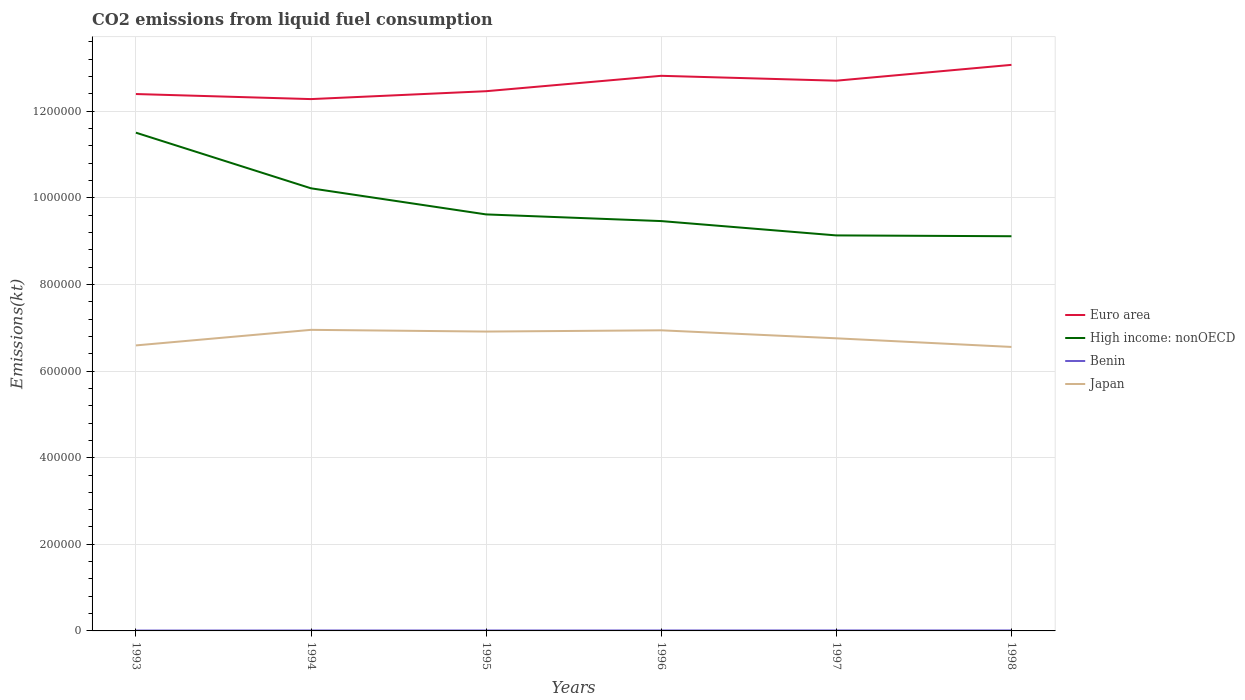Does the line corresponding to High income: nonOECD intersect with the line corresponding to Japan?
Give a very brief answer. No. Across all years, what is the maximum amount of CO2 emitted in Japan?
Your answer should be compact. 6.56e+05. What is the total amount of CO2 emitted in Euro area in the graph?
Your answer should be very brief. -6538.26. What is the difference between the highest and the second highest amount of CO2 emitted in Japan?
Provide a succinct answer. 3.95e+04. Is the amount of CO2 emitted in Euro area strictly greater than the amount of CO2 emitted in Benin over the years?
Your answer should be very brief. No. How many lines are there?
Make the answer very short. 4. How many years are there in the graph?
Provide a succinct answer. 6. Are the values on the major ticks of Y-axis written in scientific E-notation?
Offer a terse response. No. Where does the legend appear in the graph?
Provide a short and direct response. Center right. What is the title of the graph?
Keep it short and to the point. CO2 emissions from liquid fuel consumption. What is the label or title of the X-axis?
Your answer should be compact. Years. What is the label or title of the Y-axis?
Provide a short and direct response. Emissions(kt). What is the Emissions(kt) of Euro area in 1993?
Your answer should be very brief. 1.24e+06. What is the Emissions(kt) in High income: nonOECD in 1993?
Offer a very short reply. 1.15e+06. What is the Emissions(kt) of Benin in 1993?
Your answer should be compact. 880.08. What is the Emissions(kt) of Japan in 1993?
Provide a succinct answer. 6.59e+05. What is the Emissions(kt) of Euro area in 1994?
Your answer should be compact. 1.23e+06. What is the Emissions(kt) in High income: nonOECD in 1994?
Make the answer very short. 1.02e+06. What is the Emissions(kt) in Benin in 1994?
Keep it short and to the point. 1034.09. What is the Emissions(kt) in Japan in 1994?
Make the answer very short. 6.95e+05. What is the Emissions(kt) of Euro area in 1995?
Ensure brevity in your answer.  1.25e+06. What is the Emissions(kt) in High income: nonOECD in 1995?
Make the answer very short. 9.62e+05. What is the Emissions(kt) of Benin in 1995?
Your answer should be very brief. 1037.76. What is the Emissions(kt) of Japan in 1995?
Keep it short and to the point. 6.91e+05. What is the Emissions(kt) of Euro area in 1996?
Your answer should be compact. 1.28e+06. What is the Emissions(kt) of High income: nonOECD in 1996?
Keep it short and to the point. 9.46e+05. What is the Emissions(kt) of Benin in 1996?
Provide a short and direct response. 1085.43. What is the Emissions(kt) of Japan in 1996?
Keep it short and to the point. 6.94e+05. What is the Emissions(kt) in Euro area in 1997?
Your answer should be very brief. 1.27e+06. What is the Emissions(kt) of High income: nonOECD in 1997?
Make the answer very short. 9.13e+05. What is the Emissions(kt) in Benin in 1997?
Provide a succinct answer. 1118.43. What is the Emissions(kt) in Japan in 1997?
Provide a short and direct response. 6.76e+05. What is the Emissions(kt) in Euro area in 1998?
Your answer should be very brief. 1.31e+06. What is the Emissions(kt) in High income: nonOECD in 1998?
Ensure brevity in your answer.  9.11e+05. What is the Emissions(kt) in Benin in 1998?
Offer a very short reply. 1114.77. What is the Emissions(kt) of Japan in 1998?
Your answer should be very brief. 6.56e+05. Across all years, what is the maximum Emissions(kt) in Euro area?
Offer a terse response. 1.31e+06. Across all years, what is the maximum Emissions(kt) in High income: nonOECD?
Offer a very short reply. 1.15e+06. Across all years, what is the maximum Emissions(kt) of Benin?
Offer a terse response. 1118.43. Across all years, what is the maximum Emissions(kt) of Japan?
Give a very brief answer. 6.95e+05. Across all years, what is the minimum Emissions(kt) of Euro area?
Provide a short and direct response. 1.23e+06. Across all years, what is the minimum Emissions(kt) in High income: nonOECD?
Ensure brevity in your answer.  9.11e+05. Across all years, what is the minimum Emissions(kt) in Benin?
Provide a succinct answer. 880.08. Across all years, what is the minimum Emissions(kt) in Japan?
Provide a succinct answer. 6.56e+05. What is the total Emissions(kt) in Euro area in the graph?
Keep it short and to the point. 7.57e+06. What is the total Emissions(kt) in High income: nonOECD in the graph?
Ensure brevity in your answer.  5.91e+06. What is the total Emissions(kt) in Benin in the graph?
Give a very brief answer. 6270.57. What is the total Emissions(kt) of Japan in the graph?
Offer a terse response. 4.07e+06. What is the difference between the Emissions(kt) in Euro area in 1993 and that in 1994?
Make the answer very short. 1.17e+04. What is the difference between the Emissions(kt) in High income: nonOECD in 1993 and that in 1994?
Make the answer very short. 1.29e+05. What is the difference between the Emissions(kt) of Benin in 1993 and that in 1994?
Make the answer very short. -154.01. What is the difference between the Emissions(kt) in Japan in 1993 and that in 1994?
Give a very brief answer. -3.60e+04. What is the difference between the Emissions(kt) of Euro area in 1993 and that in 1995?
Ensure brevity in your answer.  -6538.26. What is the difference between the Emissions(kt) in High income: nonOECD in 1993 and that in 1995?
Provide a short and direct response. 1.89e+05. What is the difference between the Emissions(kt) in Benin in 1993 and that in 1995?
Give a very brief answer. -157.68. What is the difference between the Emissions(kt) of Japan in 1993 and that in 1995?
Your response must be concise. -3.20e+04. What is the difference between the Emissions(kt) of Euro area in 1993 and that in 1996?
Your answer should be very brief. -4.21e+04. What is the difference between the Emissions(kt) in High income: nonOECD in 1993 and that in 1996?
Keep it short and to the point. 2.04e+05. What is the difference between the Emissions(kt) in Benin in 1993 and that in 1996?
Provide a short and direct response. -205.35. What is the difference between the Emissions(kt) in Japan in 1993 and that in 1996?
Offer a terse response. -3.49e+04. What is the difference between the Emissions(kt) in Euro area in 1993 and that in 1997?
Your answer should be compact. -3.08e+04. What is the difference between the Emissions(kt) in High income: nonOECD in 1993 and that in 1997?
Provide a short and direct response. 2.37e+05. What is the difference between the Emissions(kt) in Benin in 1993 and that in 1997?
Your answer should be compact. -238.35. What is the difference between the Emissions(kt) in Japan in 1993 and that in 1997?
Provide a short and direct response. -1.64e+04. What is the difference between the Emissions(kt) in Euro area in 1993 and that in 1998?
Give a very brief answer. -6.74e+04. What is the difference between the Emissions(kt) of High income: nonOECD in 1993 and that in 1998?
Your response must be concise. 2.39e+05. What is the difference between the Emissions(kt) in Benin in 1993 and that in 1998?
Keep it short and to the point. -234.69. What is the difference between the Emissions(kt) of Japan in 1993 and that in 1998?
Provide a short and direct response. 3527.65. What is the difference between the Emissions(kt) of Euro area in 1994 and that in 1995?
Your response must be concise. -1.82e+04. What is the difference between the Emissions(kt) in High income: nonOECD in 1994 and that in 1995?
Offer a very short reply. 6.02e+04. What is the difference between the Emissions(kt) of Benin in 1994 and that in 1995?
Your response must be concise. -3.67. What is the difference between the Emissions(kt) of Japan in 1994 and that in 1995?
Your answer should be very brief. 3967.69. What is the difference between the Emissions(kt) of Euro area in 1994 and that in 1996?
Provide a succinct answer. -5.38e+04. What is the difference between the Emissions(kt) in High income: nonOECD in 1994 and that in 1996?
Ensure brevity in your answer.  7.56e+04. What is the difference between the Emissions(kt) in Benin in 1994 and that in 1996?
Your answer should be compact. -51.34. What is the difference between the Emissions(kt) in Japan in 1994 and that in 1996?
Your response must be concise. 1092.77. What is the difference between the Emissions(kt) of Euro area in 1994 and that in 1997?
Provide a short and direct response. -4.25e+04. What is the difference between the Emissions(kt) in High income: nonOECD in 1994 and that in 1997?
Provide a short and direct response. 1.09e+05. What is the difference between the Emissions(kt) of Benin in 1994 and that in 1997?
Your response must be concise. -84.34. What is the difference between the Emissions(kt) of Japan in 1994 and that in 1997?
Your answer should be very brief. 1.96e+04. What is the difference between the Emissions(kt) in Euro area in 1994 and that in 1998?
Provide a short and direct response. -7.91e+04. What is the difference between the Emissions(kt) in High income: nonOECD in 1994 and that in 1998?
Make the answer very short. 1.11e+05. What is the difference between the Emissions(kt) in Benin in 1994 and that in 1998?
Offer a terse response. -80.67. What is the difference between the Emissions(kt) in Japan in 1994 and that in 1998?
Your response must be concise. 3.95e+04. What is the difference between the Emissions(kt) of Euro area in 1995 and that in 1996?
Your answer should be compact. -3.56e+04. What is the difference between the Emissions(kt) of High income: nonOECD in 1995 and that in 1996?
Provide a short and direct response. 1.54e+04. What is the difference between the Emissions(kt) of Benin in 1995 and that in 1996?
Your answer should be compact. -47.67. What is the difference between the Emissions(kt) of Japan in 1995 and that in 1996?
Give a very brief answer. -2874.93. What is the difference between the Emissions(kt) of Euro area in 1995 and that in 1997?
Keep it short and to the point. -2.43e+04. What is the difference between the Emissions(kt) of High income: nonOECD in 1995 and that in 1997?
Provide a short and direct response. 4.85e+04. What is the difference between the Emissions(kt) of Benin in 1995 and that in 1997?
Your answer should be compact. -80.67. What is the difference between the Emissions(kt) of Japan in 1995 and that in 1997?
Your answer should be compact. 1.56e+04. What is the difference between the Emissions(kt) of Euro area in 1995 and that in 1998?
Make the answer very short. -6.08e+04. What is the difference between the Emissions(kt) of High income: nonOECD in 1995 and that in 1998?
Keep it short and to the point. 5.04e+04. What is the difference between the Emissions(kt) of Benin in 1995 and that in 1998?
Provide a succinct answer. -77.01. What is the difference between the Emissions(kt) in Japan in 1995 and that in 1998?
Provide a succinct answer. 3.55e+04. What is the difference between the Emissions(kt) in Euro area in 1996 and that in 1997?
Provide a short and direct response. 1.13e+04. What is the difference between the Emissions(kt) of High income: nonOECD in 1996 and that in 1997?
Ensure brevity in your answer.  3.31e+04. What is the difference between the Emissions(kt) in Benin in 1996 and that in 1997?
Provide a succinct answer. -33. What is the difference between the Emissions(kt) in Japan in 1996 and that in 1997?
Keep it short and to the point. 1.85e+04. What is the difference between the Emissions(kt) of Euro area in 1996 and that in 1998?
Offer a terse response. -2.53e+04. What is the difference between the Emissions(kt) of High income: nonOECD in 1996 and that in 1998?
Provide a short and direct response. 3.50e+04. What is the difference between the Emissions(kt) of Benin in 1996 and that in 1998?
Your answer should be very brief. -29.34. What is the difference between the Emissions(kt) in Japan in 1996 and that in 1998?
Offer a terse response. 3.84e+04. What is the difference between the Emissions(kt) of Euro area in 1997 and that in 1998?
Provide a short and direct response. -3.66e+04. What is the difference between the Emissions(kt) of High income: nonOECD in 1997 and that in 1998?
Provide a succinct answer. 1889.15. What is the difference between the Emissions(kt) in Benin in 1997 and that in 1998?
Keep it short and to the point. 3.67. What is the difference between the Emissions(kt) in Japan in 1997 and that in 1998?
Keep it short and to the point. 1.99e+04. What is the difference between the Emissions(kt) of Euro area in 1993 and the Emissions(kt) of High income: nonOECD in 1994?
Keep it short and to the point. 2.18e+05. What is the difference between the Emissions(kt) of Euro area in 1993 and the Emissions(kt) of Benin in 1994?
Your answer should be compact. 1.24e+06. What is the difference between the Emissions(kt) of Euro area in 1993 and the Emissions(kt) of Japan in 1994?
Your answer should be compact. 5.44e+05. What is the difference between the Emissions(kt) in High income: nonOECD in 1993 and the Emissions(kt) in Benin in 1994?
Make the answer very short. 1.15e+06. What is the difference between the Emissions(kt) of High income: nonOECD in 1993 and the Emissions(kt) of Japan in 1994?
Your answer should be very brief. 4.55e+05. What is the difference between the Emissions(kt) of Benin in 1993 and the Emissions(kt) of Japan in 1994?
Make the answer very short. -6.94e+05. What is the difference between the Emissions(kt) in Euro area in 1993 and the Emissions(kt) in High income: nonOECD in 1995?
Give a very brief answer. 2.78e+05. What is the difference between the Emissions(kt) in Euro area in 1993 and the Emissions(kt) in Benin in 1995?
Provide a succinct answer. 1.24e+06. What is the difference between the Emissions(kt) of Euro area in 1993 and the Emissions(kt) of Japan in 1995?
Ensure brevity in your answer.  5.48e+05. What is the difference between the Emissions(kt) of High income: nonOECD in 1993 and the Emissions(kt) of Benin in 1995?
Your response must be concise. 1.15e+06. What is the difference between the Emissions(kt) in High income: nonOECD in 1993 and the Emissions(kt) in Japan in 1995?
Offer a terse response. 4.59e+05. What is the difference between the Emissions(kt) in Benin in 1993 and the Emissions(kt) in Japan in 1995?
Keep it short and to the point. -6.90e+05. What is the difference between the Emissions(kt) in Euro area in 1993 and the Emissions(kt) in High income: nonOECD in 1996?
Provide a short and direct response. 2.93e+05. What is the difference between the Emissions(kt) of Euro area in 1993 and the Emissions(kt) of Benin in 1996?
Give a very brief answer. 1.24e+06. What is the difference between the Emissions(kt) in Euro area in 1993 and the Emissions(kt) in Japan in 1996?
Your answer should be compact. 5.46e+05. What is the difference between the Emissions(kt) in High income: nonOECD in 1993 and the Emissions(kt) in Benin in 1996?
Ensure brevity in your answer.  1.15e+06. What is the difference between the Emissions(kt) of High income: nonOECD in 1993 and the Emissions(kt) of Japan in 1996?
Keep it short and to the point. 4.56e+05. What is the difference between the Emissions(kt) in Benin in 1993 and the Emissions(kt) in Japan in 1996?
Offer a very short reply. -6.93e+05. What is the difference between the Emissions(kt) in Euro area in 1993 and the Emissions(kt) in High income: nonOECD in 1997?
Provide a short and direct response. 3.26e+05. What is the difference between the Emissions(kt) in Euro area in 1993 and the Emissions(kt) in Benin in 1997?
Make the answer very short. 1.24e+06. What is the difference between the Emissions(kt) in Euro area in 1993 and the Emissions(kt) in Japan in 1997?
Your answer should be compact. 5.64e+05. What is the difference between the Emissions(kt) in High income: nonOECD in 1993 and the Emissions(kt) in Benin in 1997?
Your answer should be very brief. 1.15e+06. What is the difference between the Emissions(kt) of High income: nonOECD in 1993 and the Emissions(kt) of Japan in 1997?
Offer a very short reply. 4.75e+05. What is the difference between the Emissions(kt) of Benin in 1993 and the Emissions(kt) of Japan in 1997?
Provide a succinct answer. -6.75e+05. What is the difference between the Emissions(kt) of Euro area in 1993 and the Emissions(kt) of High income: nonOECD in 1998?
Provide a short and direct response. 3.28e+05. What is the difference between the Emissions(kt) in Euro area in 1993 and the Emissions(kt) in Benin in 1998?
Provide a short and direct response. 1.24e+06. What is the difference between the Emissions(kt) in Euro area in 1993 and the Emissions(kt) in Japan in 1998?
Ensure brevity in your answer.  5.84e+05. What is the difference between the Emissions(kt) of High income: nonOECD in 1993 and the Emissions(kt) of Benin in 1998?
Keep it short and to the point. 1.15e+06. What is the difference between the Emissions(kt) in High income: nonOECD in 1993 and the Emissions(kt) in Japan in 1998?
Provide a short and direct response. 4.95e+05. What is the difference between the Emissions(kt) of Benin in 1993 and the Emissions(kt) of Japan in 1998?
Your response must be concise. -6.55e+05. What is the difference between the Emissions(kt) in Euro area in 1994 and the Emissions(kt) in High income: nonOECD in 1995?
Make the answer very short. 2.66e+05. What is the difference between the Emissions(kt) in Euro area in 1994 and the Emissions(kt) in Benin in 1995?
Your response must be concise. 1.23e+06. What is the difference between the Emissions(kt) of Euro area in 1994 and the Emissions(kt) of Japan in 1995?
Ensure brevity in your answer.  5.37e+05. What is the difference between the Emissions(kt) of High income: nonOECD in 1994 and the Emissions(kt) of Benin in 1995?
Give a very brief answer. 1.02e+06. What is the difference between the Emissions(kt) in High income: nonOECD in 1994 and the Emissions(kt) in Japan in 1995?
Your response must be concise. 3.31e+05. What is the difference between the Emissions(kt) of Benin in 1994 and the Emissions(kt) of Japan in 1995?
Give a very brief answer. -6.90e+05. What is the difference between the Emissions(kt) in Euro area in 1994 and the Emissions(kt) in High income: nonOECD in 1996?
Give a very brief answer. 2.82e+05. What is the difference between the Emissions(kt) in Euro area in 1994 and the Emissions(kt) in Benin in 1996?
Ensure brevity in your answer.  1.23e+06. What is the difference between the Emissions(kt) in Euro area in 1994 and the Emissions(kt) in Japan in 1996?
Offer a very short reply. 5.34e+05. What is the difference between the Emissions(kt) of High income: nonOECD in 1994 and the Emissions(kt) of Benin in 1996?
Ensure brevity in your answer.  1.02e+06. What is the difference between the Emissions(kt) of High income: nonOECD in 1994 and the Emissions(kt) of Japan in 1996?
Make the answer very short. 3.28e+05. What is the difference between the Emissions(kt) of Benin in 1994 and the Emissions(kt) of Japan in 1996?
Offer a terse response. -6.93e+05. What is the difference between the Emissions(kt) in Euro area in 1994 and the Emissions(kt) in High income: nonOECD in 1997?
Provide a short and direct response. 3.15e+05. What is the difference between the Emissions(kt) of Euro area in 1994 and the Emissions(kt) of Benin in 1997?
Offer a very short reply. 1.23e+06. What is the difference between the Emissions(kt) in Euro area in 1994 and the Emissions(kt) in Japan in 1997?
Provide a succinct answer. 5.52e+05. What is the difference between the Emissions(kt) of High income: nonOECD in 1994 and the Emissions(kt) of Benin in 1997?
Your answer should be compact. 1.02e+06. What is the difference between the Emissions(kt) in High income: nonOECD in 1994 and the Emissions(kt) in Japan in 1997?
Your answer should be very brief. 3.46e+05. What is the difference between the Emissions(kt) of Benin in 1994 and the Emissions(kt) of Japan in 1997?
Make the answer very short. -6.75e+05. What is the difference between the Emissions(kt) in Euro area in 1994 and the Emissions(kt) in High income: nonOECD in 1998?
Offer a terse response. 3.17e+05. What is the difference between the Emissions(kt) in Euro area in 1994 and the Emissions(kt) in Benin in 1998?
Ensure brevity in your answer.  1.23e+06. What is the difference between the Emissions(kt) of Euro area in 1994 and the Emissions(kt) of Japan in 1998?
Make the answer very short. 5.72e+05. What is the difference between the Emissions(kt) of High income: nonOECD in 1994 and the Emissions(kt) of Benin in 1998?
Offer a very short reply. 1.02e+06. What is the difference between the Emissions(kt) in High income: nonOECD in 1994 and the Emissions(kt) in Japan in 1998?
Your answer should be very brief. 3.66e+05. What is the difference between the Emissions(kt) of Benin in 1994 and the Emissions(kt) of Japan in 1998?
Your response must be concise. -6.55e+05. What is the difference between the Emissions(kt) in Euro area in 1995 and the Emissions(kt) in High income: nonOECD in 1996?
Keep it short and to the point. 3.00e+05. What is the difference between the Emissions(kt) in Euro area in 1995 and the Emissions(kt) in Benin in 1996?
Ensure brevity in your answer.  1.25e+06. What is the difference between the Emissions(kt) of Euro area in 1995 and the Emissions(kt) of Japan in 1996?
Keep it short and to the point. 5.52e+05. What is the difference between the Emissions(kt) of High income: nonOECD in 1995 and the Emissions(kt) of Benin in 1996?
Provide a short and direct response. 9.61e+05. What is the difference between the Emissions(kt) in High income: nonOECD in 1995 and the Emissions(kt) in Japan in 1996?
Ensure brevity in your answer.  2.68e+05. What is the difference between the Emissions(kt) of Benin in 1995 and the Emissions(kt) of Japan in 1996?
Give a very brief answer. -6.93e+05. What is the difference between the Emissions(kt) in Euro area in 1995 and the Emissions(kt) in High income: nonOECD in 1997?
Offer a very short reply. 3.33e+05. What is the difference between the Emissions(kt) of Euro area in 1995 and the Emissions(kt) of Benin in 1997?
Offer a terse response. 1.25e+06. What is the difference between the Emissions(kt) in Euro area in 1995 and the Emissions(kt) in Japan in 1997?
Make the answer very short. 5.71e+05. What is the difference between the Emissions(kt) in High income: nonOECD in 1995 and the Emissions(kt) in Benin in 1997?
Offer a very short reply. 9.61e+05. What is the difference between the Emissions(kt) in High income: nonOECD in 1995 and the Emissions(kt) in Japan in 1997?
Your answer should be very brief. 2.86e+05. What is the difference between the Emissions(kt) in Benin in 1995 and the Emissions(kt) in Japan in 1997?
Your answer should be very brief. -6.75e+05. What is the difference between the Emissions(kt) in Euro area in 1995 and the Emissions(kt) in High income: nonOECD in 1998?
Offer a very short reply. 3.35e+05. What is the difference between the Emissions(kt) of Euro area in 1995 and the Emissions(kt) of Benin in 1998?
Give a very brief answer. 1.25e+06. What is the difference between the Emissions(kt) of Euro area in 1995 and the Emissions(kt) of Japan in 1998?
Provide a short and direct response. 5.91e+05. What is the difference between the Emissions(kt) of High income: nonOECD in 1995 and the Emissions(kt) of Benin in 1998?
Offer a very short reply. 9.61e+05. What is the difference between the Emissions(kt) in High income: nonOECD in 1995 and the Emissions(kt) in Japan in 1998?
Ensure brevity in your answer.  3.06e+05. What is the difference between the Emissions(kt) of Benin in 1995 and the Emissions(kt) of Japan in 1998?
Your response must be concise. -6.55e+05. What is the difference between the Emissions(kt) in Euro area in 1996 and the Emissions(kt) in High income: nonOECD in 1997?
Your answer should be very brief. 3.69e+05. What is the difference between the Emissions(kt) of Euro area in 1996 and the Emissions(kt) of Benin in 1997?
Provide a succinct answer. 1.28e+06. What is the difference between the Emissions(kt) of Euro area in 1996 and the Emissions(kt) of Japan in 1997?
Make the answer very short. 6.06e+05. What is the difference between the Emissions(kt) in High income: nonOECD in 1996 and the Emissions(kt) in Benin in 1997?
Ensure brevity in your answer.  9.45e+05. What is the difference between the Emissions(kt) of High income: nonOECD in 1996 and the Emissions(kt) of Japan in 1997?
Make the answer very short. 2.71e+05. What is the difference between the Emissions(kt) of Benin in 1996 and the Emissions(kt) of Japan in 1997?
Provide a short and direct response. -6.75e+05. What is the difference between the Emissions(kt) of Euro area in 1996 and the Emissions(kt) of High income: nonOECD in 1998?
Give a very brief answer. 3.70e+05. What is the difference between the Emissions(kt) in Euro area in 1996 and the Emissions(kt) in Benin in 1998?
Provide a short and direct response. 1.28e+06. What is the difference between the Emissions(kt) in Euro area in 1996 and the Emissions(kt) in Japan in 1998?
Provide a succinct answer. 6.26e+05. What is the difference between the Emissions(kt) of High income: nonOECD in 1996 and the Emissions(kt) of Benin in 1998?
Ensure brevity in your answer.  9.45e+05. What is the difference between the Emissions(kt) of High income: nonOECD in 1996 and the Emissions(kt) of Japan in 1998?
Ensure brevity in your answer.  2.91e+05. What is the difference between the Emissions(kt) of Benin in 1996 and the Emissions(kt) of Japan in 1998?
Your answer should be very brief. -6.55e+05. What is the difference between the Emissions(kt) in Euro area in 1997 and the Emissions(kt) in High income: nonOECD in 1998?
Give a very brief answer. 3.59e+05. What is the difference between the Emissions(kt) in Euro area in 1997 and the Emissions(kt) in Benin in 1998?
Offer a terse response. 1.27e+06. What is the difference between the Emissions(kt) of Euro area in 1997 and the Emissions(kt) of Japan in 1998?
Ensure brevity in your answer.  6.15e+05. What is the difference between the Emissions(kt) of High income: nonOECD in 1997 and the Emissions(kt) of Benin in 1998?
Provide a short and direct response. 9.12e+05. What is the difference between the Emissions(kt) of High income: nonOECD in 1997 and the Emissions(kt) of Japan in 1998?
Provide a short and direct response. 2.58e+05. What is the difference between the Emissions(kt) in Benin in 1997 and the Emissions(kt) in Japan in 1998?
Keep it short and to the point. -6.55e+05. What is the average Emissions(kt) of Euro area per year?
Your answer should be very brief. 1.26e+06. What is the average Emissions(kt) of High income: nonOECD per year?
Keep it short and to the point. 9.84e+05. What is the average Emissions(kt) in Benin per year?
Offer a very short reply. 1045.1. What is the average Emissions(kt) of Japan per year?
Offer a terse response. 6.79e+05. In the year 1993, what is the difference between the Emissions(kt) in Euro area and Emissions(kt) in High income: nonOECD?
Make the answer very short. 8.92e+04. In the year 1993, what is the difference between the Emissions(kt) in Euro area and Emissions(kt) in Benin?
Make the answer very short. 1.24e+06. In the year 1993, what is the difference between the Emissions(kt) in Euro area and Emissions(kt) in Japan?
Keep it short and to the point. 5.80e+05. In the year 1993, what is the difference between the Emissions(kt) in High income: nonOECD and Emissions(kt) in Benin?
Offer a very short reply. 1.15e+06. In the year 1993, what is the difference between the Emissions(kt) of High income: nonOECD and Emissions(kt) of Japan?
Offer a very short reply. 4.91e+05. In the year 1993, what is the difference between the Emissions(kt) in Benin and Emissions(kt) in Japan?
Offer a very short reply. -6.58e+05. In the year 1994, what is the difference between the Emissions(kt) in Euro area and Emissions(kt) in High income: nonOECD?
Offer a terse response. 2.06e+05. In the year 1994, what is the difference between the Emissions(kt) of Euro area and Emissions(kt) of Benin?
Provide a short and direct response. 1.23e+06. In the year 1994, what is the difference between the Emissions(kt) of Euro area and Emissions(kt) of Japan?
Offer a terse response. 5.33e+05. In the year 1994, what is the difference between the Emissions(kt) in High income: nonOECD and Emissions(kt) in Benin?
Your answer should be very brief. 1.02e+06. In the year 1994, what is the difference between the Emissions(kt) of High income: nonOECD and Emissions(kt) of Japan?
Make the answer very short. 3.27e+05. In the year 1994, what is the difference between the Emissions(kt) of Benin and Emissions(kt) of Japan?
Provide a succinct answer. -6.94e+05. In the year 1995, what is the difference between the Emissions(kt) of Euro area and Emissions(kt) of High income: nonOECD?
Ensure brevity in your answer.  2.84e+05. In the year 1995, what is the difference between the Emissions(kt) of Euro area and Emissions(kt) of Benin?
Ensure brevity in your answer.  1.25e+06. In the year 1995, what is the difference between the Emissions(kt) in Euro area and Emissions(kt) in Japan?
Offer a terse response. 5.55e+05. In the year 1995, what is the difference between the Emissions(kt) in High income: nonOECD and Emissions(kt) in Benin?
Your answer should be very brief. 9.61e+05. In the year 1995, what is the difference between the Emissions(kt) in High income: nonOECD and Emissions(kt) in Japan?
Make the answer very short. 2.71e+05. In the year 1995, what is the difference between the Emissions(kt) in Benin and Emissions(kt) in Japan?
Offer a very short reply. -6.90e+05. In the year 1996, what is the difference between the Emissions(kt) in Euro area and Emissions(kt) in High income: nonOECD?
Make the answer very short. 3.35e+05. In the year 1996, what is the difference between the Emissions(kt) of Euro area and Emissions(kt) of Benin?
Your answer should be compact. 1.28e+06. In the year 1996, what is the difference between the Emissions(kt) in Euro area and Emissions(kt) in Japan?
Keep it short and to the point. 5.88e+05. In the year 1996, what is the difference between the Emissions(kt) in High income: nonOECD and Emissions(kt) in Benin?
Keep it short and to the point. 9.45e+05. In the year 1996, what is the difference between the Emissions(kt) in High income: nonOECD and Emissions(kt) in Japan?
Provide a succinct answer. 2.52e+05. In the year 1996, what is the difference between the Emissions(kt) of Benin and Emissions(kt) of Japan?
Provide a succinct answer. -6.93e+05. In the year 1997, what is the difference between the Emissions(kt) of Euro area and Emissions(kt) of High income: nonOECD?
Your answer should be compact. 3.57e+05. In the year 1997, what is the difference between the Emissions(kt) in Euro area and Emissions(kt) in Benin?
Ensure brevity in your answer.  1.27e+06. In the year 1997, what is the difference between the Emissions(kt) in Euro area and Emissions(kt) in Japan?
Your answer should be compact. 5.95e+05. In the year 1997, what is the difference between the Emissions(kt) in High income: nonOECD and Emissions(kt) in Benin?
Your response must be concise. 9.12e+05. In the year 1997, what is the difference between the Emissions(kt) in High income: nonOECD and Emissions(kt) in Japan?
Your answer should be compact. 2.38e+05. In the year 1997, what is the difference between the Emissions(kt) in Benin and Emissions(kt) in Japan?
Your response must be concise. -6.75e+05. In the year 1998, what is the difference between the Emissions(kt) of Euro area and Emissions(kt) of High income: nonOECD?
Your response must be concise. 3.96e+05. In the year 1998, what is the difference between the Emissions(kt) in Euro area and Emissions(kt) in Benin?
Provide a short and direct response. 1.31e+06. In the year 1998, what is the difference between the Emissions(kt) in Euro area and Emissions(kt) in Japan?
Keep it short and to the point. 6.51e+05. In the year 1998, what is the difference between the Emissions(kt) in High income: nonOECD and Emissions(kt) in Benin?
Ensure brevity in your answer.  9.10e+05. In the year 1998, what is the difference between the Emissions(kt) in High income: nonOECD and Emissions(kt) in Japan?
Ensure brevity in your answer.  2.56e+05. In the year 1998, what is the difference between the Emissions(kt) of Benin and Emissions(kt) of Japan?
Ensure brevity in your answer.  -6.55e+05. What is the ratio of the Emissions(kt) of Euro area in 1993 to that in 1994?
Provide a short and direct response. 1.01. What is the ratio of the Emissions(kt) in High income: nonOECD in 1993 to that in 1994?
Ensure brevity in your answer.  1.13. What is the ratio of the Emissions(kt) in Benin in 1993 to that in 1994?
Your response must be concise. 0.85. What is the ratio of the Emissions(kt) of Japan in 1993 to that in 1994?
Ensure brevity in your answer.  0.95. What is the ratio of the Emissions(kt) of Euro area in 1993 to that in 1995?
Your answer should be very brief. 0.99. What is the ratio of the Emissions(kt) in High income: nonOECD in 1993 to that in 1995?
Offer a terse response. 1.2. What is the ratio of the Emissions(kt) in Benin in 1993 to that in 1995?
Keep it short and to the point. 0.85. What is the ratio of the Emissions(kt) in Japan in 1993 to that in 1995?
Give a very brief answer. 0.95. What is the ratio of the Emissions(kt) in Euro area in 1993 to that in 1996?
Offer a terse response. 0.97. What is the ratio of the Emissions(kt) of High income: nonOECD in 1993 to that in 1996?
Your response must be concise. 1.22. What is the ratio of the Emissions(kt) in Benin in 1993 to that in 1996?
Give a very brief answer. 0.81. What is the ratio of the Emissions(kt) in Japan in 1993 to that in 1996?
Ensure brevity in your answer.  0.95. What is the ratio of the Emissions(kt) of Euro area in 1993 to that in 1997?
Provide a succinct answer. 0.98. What is the ratio of the Emissions(kt) in High income: nonOECD in 1993 to that in 1997?
Your answer should be very brief. 1.26. What is the ratio of the Emissions(kt) of Benin in 1993 to that in 1997?
Your answer should be very brief. 0.79. What is the ratio of the Emissions(kt) of Japan in 1993 to that in 1997?
Provide a succinct answer. 0.98. What is the ratio of the Emissions(kt) in Euro area in 1993 to that in 1998?
Keep it short and to the point. 0.95. What is the ratio of the Emissions(kt) of High income: nonOECD in 1993 to that in 1998?
Offer a terse response. 1.26. What is the ratio of the Emissions(kt) of Benin in 1993 to that in 1998?
Give a very brief answer. 0.79. What is the ratio of the Emissions(kt) of Japan in 1993 to that in 1998?
Ensure brevity in your answer.  1.01. What is the ratio of the Emissions(kt) in Euro area in 1994 to that in 1995?
Provide a succinct answer. 0.99. What is the ratio of the Emissions(kt) in High income: nonOECD in 1994 to that in 1995?
Offer a very short reply. 1.06. What is the ratio of the Emissions(kt) of Benin in 1994 to that in 1995?
Ensure brevity in your answer.  1. What is the ratio of the Emissions(kt) of Japan in 1994 to that in 1995?
Offer a terse response. 1.01. What is the ratio of the Emissions(kt) in Euro area in 1994 to that in 1996?
Provide a succinct answer. 0.96. What is the ratio of the Emissions(kt) in High income: nonOECD in 1994 to that in 1996?
Provide a short and direct response. 1.08. What is the ratio of the Emissions(kt) of Benin in 1994 to that in 1996?
Ensure brevity in your answer.  0.95. What is the ratio of the Emissions(kt) in Japan in 1994 to that in 1996?
Your answer should be very brief. 1. What is the ratio of the Emissions(kt) of Euro area in 1994 to that in 1997?
Give a very brief answer. 0.97. What is the ratio of the Emissions(kt) in High income: nonOECD in 1994 to that in 1997?
Provide a succinct answer. 1.12. What is the ratio of the Emissions(kt) of Benin in 1994 to that in 1997?
Give a very brief answer. 0.92. What is the ratio of the Emissions(kt) of Japan in 1994 to that in 1997?
Provide a short and direct response. 1.03. What is the ratio of the Emissions(kt) of Euro area in 1994 to that in 1998?
Offer a terse response. 0.94. What is the ratio of the Emissions(kt) in High income: nonOECD in 1994 to that in 1998?
Your response must be concise. 1.12. What is the ratio of the Emissions(kt) of Benin in 1994 to that in 1998?
Your answer should be compact. 0.93. What is the ratio of the Emissions(kt) in Japan in 1994 to that in 1998?
Your response must be concise. 1.06. What is the ratio of the Emissions(kt) in Euro area in 1995 to that in 1996?
Provide a succinct answer. 0.97. What is the ratio of the Emissions(kt) in High income: nonOECD in 1995 to that in 1996?
Your answer should be very brief. 1.02. What is the ratio of the Emissions(kt) in Benin in 1995 to that in 1996?
Provide a succinct answer. 0.96. What is the ratio of the Emissions(kt) in Euro area in 1995 to that in 1997?
Your response must be concise. 0.98. What is the ratio of the Emissions(kt) of High income: nonOECD in 1995 to that in 1997?
Make the answer very short. 1.05. What is the ratio of the Emissions(kt) of Benin in 1995 to that in 1997?
Make the answer very short. 0.93. What is the ratio of the Emissions(kt) of Japan in 1995 to that in 1997?
Your response must be concise. 1.02. What is the ratio of the Emissions(kt) in Euro area in 1995 to that in 1998?
Offer a terse response. 0.95. What is the ratio of the Emissions(kt) of High income: nonOECD in 1995 to that in 1998?
Your answer should be very brief. 1.06. What is the ratio of the Emissions(kt) of Benin in 1995 to that in 1998?
Provide a short and direct response. 0.93. What is the ratio of the Emissions(kt) in Japan in 1995 to that in 1998?
Give a very brief answer. 1.05. What is the ratio of the Emissions(kt) in Euro area in 1996 to that in 1997?
Offer a terse response. 1.01. What is the ratio of the Emissions(kt) of High income: nonOECD in 1996 to that in 1997?
Make the answer very short. 1.04. What is the ratio of the Emissions(kt) of Benin in 1996 to that in 1997?
Your answer should be compact. 0.97. What is the ratio of the Emissions(kt) of Japan in 1996 to that in 1997?
Your answer should be very brief. 1.03. What is the ratio of the Emissions(kt) in Euro area in 1996 to that in 1998?
Ensure brevity in your answer.  0.98. What is the ratio of the Emissions(kt) of High income: nonOECD in 1996 to that in 1998?
Your answer should be compact. 1.04. What is the ratio of the Emissions(kt) of Benin in 1996 to that in 1998?
Offer a very short reply. 0.97. What is the ratio of the Emissions(kt) of Japan in 1996 to that in 1998?
Your response must be concise. 1.06. What is the ratio of the Emissions(kt) in Japan in 1997 to that in 1998?
Provide a short and direct response. 1.03. What is the difference between the highest and the second highest Emissions(kt) in Euro area?
Your answer should be compact. 2.53e+04. What is the difference between the highest and the second highest Emissions(kt) in High income: nonOECD?
Your answer should be very brief. 1.29e+05. What is the difference between the highest and the second highest Emissions(kt) of Benin?
Offer a very short reply. 3.67. What is the difference between the highest and the second highest Emissions(kt) in Japan?
Keep it short and to the point. 1092.77. What is the difference between the highest and the lowest Emissions(kt) in Euro area?
Your answer should be compact. 7.91e+04. What is the difference between the highest and the lowest Emissions(kt) in High income: nonOECD?
Make the answer very short. 2.39e+05. What is the difference between the highest and the lowest Emissions(kt) in Benin?
Provide a succinct answer. 238.35. What is the difference between the highest and the lowest Emissions(kt) of Japan?
Provide a short and direct response. 3.95e+04. 